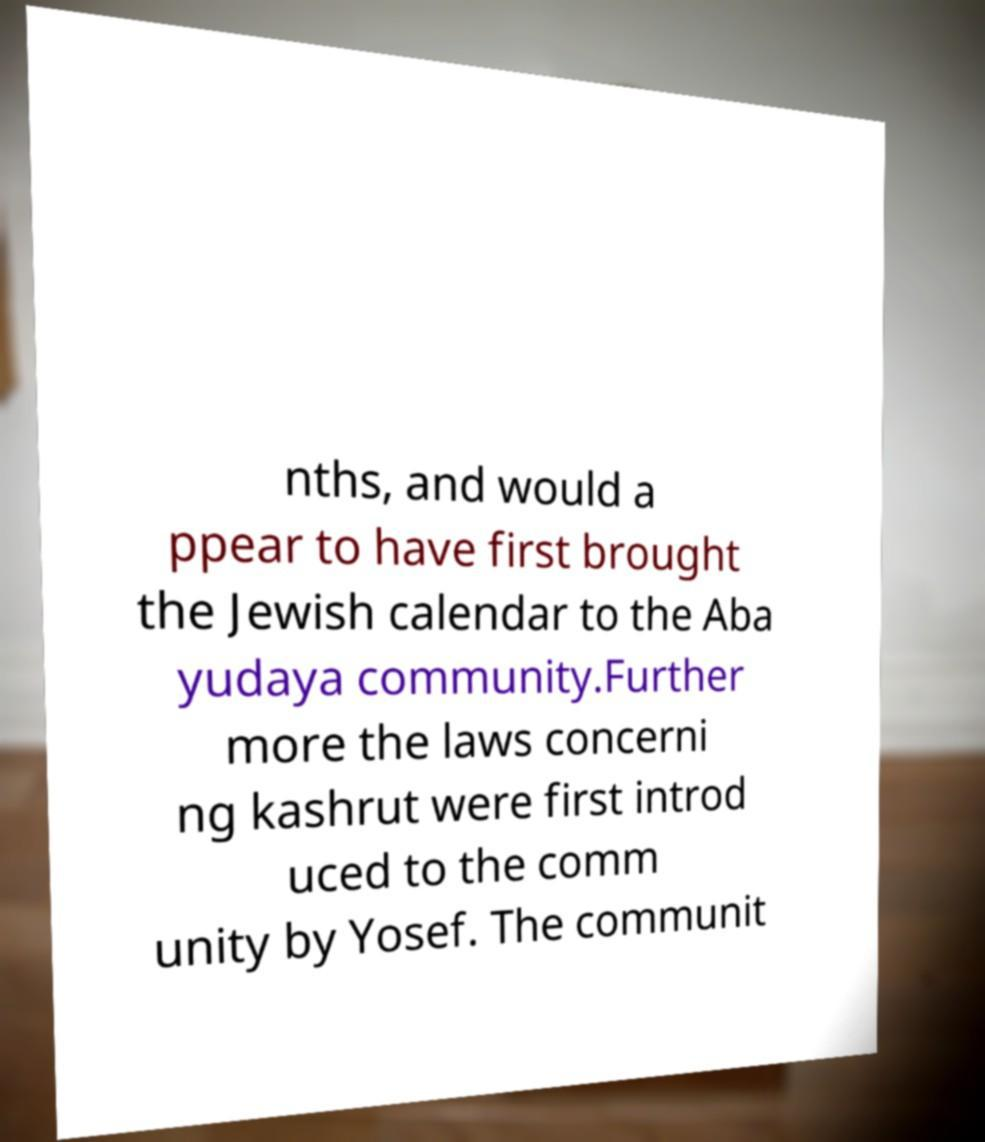For documentation purposes, I need the text within this image transcribed. Could you provide that? nths, and would a ppear to have first brought the Jewish calendar to the Aba yudaya community.Further more the laws concerni ng kashrut were first introd uced to the comm unity by Yosef. The communit 